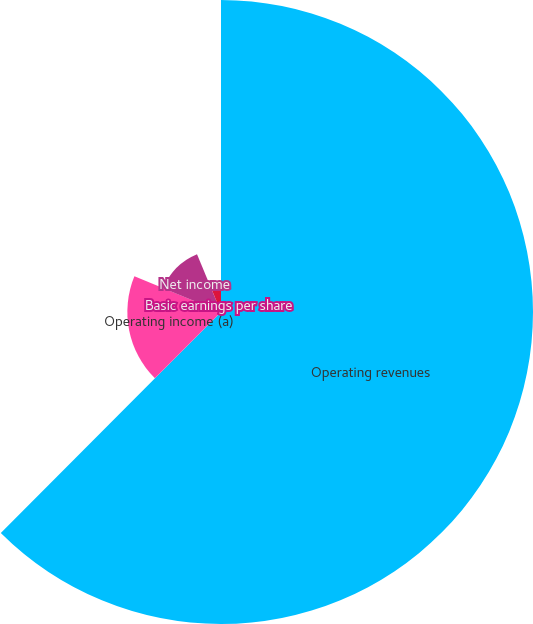<chart> <loc_0><loc_0><loc_500><loc_500><pie_chart><fcel>Operating revenues<fcel>Operating income (a)<fcel>Net income<fcel>Basic earnings per share<fcel>Diluted earnings per share<nl><fcel>62.47%<fcel>18.75%<fcel>12.51%<fcel>0.01%<fcel>6.26%<nl></chart> 